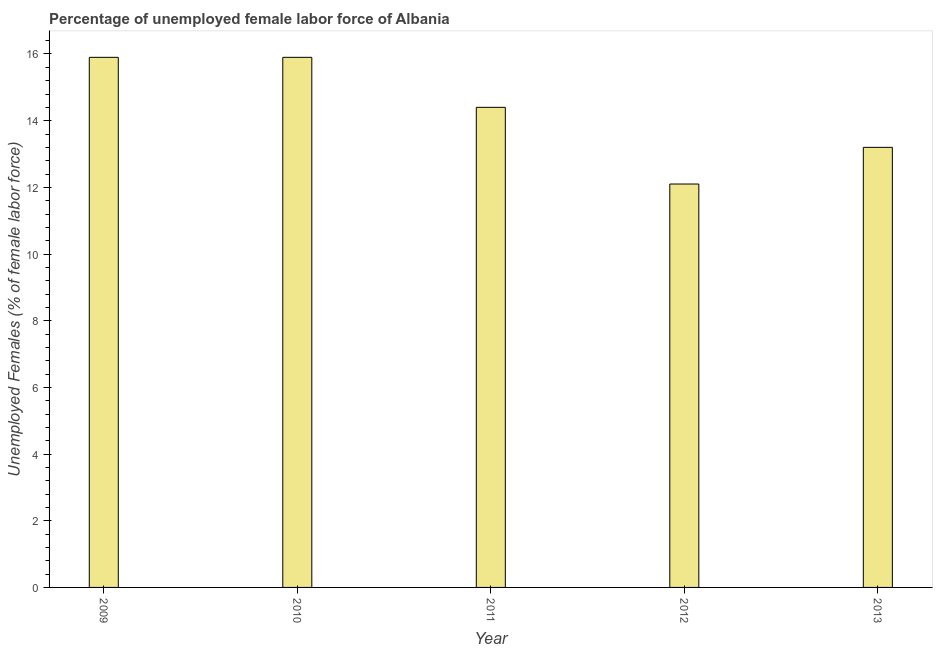Does the graph contain any zero values?
Give a very brief answer. No. Does the graph contain grids?
Keep it short and to the point. No. What is the title of the graph?
Provide a succinct answer. Percentage of unemployed female labor force of Albania. What is the label or title of the Y-axis?
Make the answer very short. Unemployed Females (% of female labor force). What is the total unemployed female labour force in 2012?
Provide a short and direct response. 12.1. Across all years, what is the maximum total unemployed female labour force?
Your response must be concise. 15.9. Across all years, what is the minimum total unemployed female labour force?
Provide a short and direct response. 12.1. In which year was the total unemployed female labour force minimum?
Offer a terse response. 2012. What is the sum of the total unemployed female labour force?
Provide a short and direct response. 71.5. What is the difference between the total unemployed female labour force in 2009 and 2012?
Ensure brevity in your answer.  3.8. What is the median total unemployed female labour force?
Give a very brief answer. 14.4. What is the ratio of the total unemployed female labour force in 2010 to that in 2012?
Offer a very short reply. 1.31. Is the difference between the total unemployed female labour force in 2012 and 2013 greater than the difference between any two years?
Provide a succinct answer. No. What is the difference between the highest and the second highest total unemployed female labour force?
Provide a succinct answer. 0. Is the sum of the total unemployed female labour force in 2009 and 2011 greater than the maximum total unemployed female labour force across all years?
Your answer should be compact. Yes. What is the difference between the highest and the lowest total unemployed female labour force?
Your answer should be compact. 3.8. Are all the bars in the graph horizontal?
Your response must be concise. No. What is the difference between two consecutive major ticks on the Y-axis?
Keep it short and to the point. 2. Are the values on the major ticks of Y-axis written in scientific E-notation?
Your answer should be compact. No. What is the Unemployed Females (% of female labor force) of 2009?
Ensure brevity in your answer.  15.9. What is the Unemployed Females (% of female labor force) of 2010?
Ensure brevity in your answer.  15.9. What is the Unemployed Females (% of female labor force) of 2011?
Make the answer very short. 14.4. What is the Unemployed Females (% of female labor force) of 2012?
Offer a terse response. 12.1. What is the Unemployed Females (% of female labor force) in 2013?
Your answer should be compact. 13.2. What is the difference between the Unemployed Females (% of female labor force) in 2009 and 2010?
Provide a short and direct response. 0. What is the difference between the Unemployed Females (% of female labor force) in 2009 and 2011?
Your answer should be compact. 1.5. What is the difference between the Unemployed Females (% of female labor force) in 2009 and 2012?
Your answer should be compact. 3.8. What is the difference between the Unemployed Females (% of female labor force) in 2010 and 2011?
Offer a very short reply. 1.5. What is the difference between the Unemployed Females (% of female labor force) in 2010 and 2012?
Your answer should be very brief. 3.8. What is the difference between the Unemployed Females (% of female labor force) in 2011 and 2012?
Provide a succinct answer. 2.3. What is the difference between the Unemployed Females (% of female labor force) in 2011 and 2013?
Give a very brief answer. 1.2. What is the ratio of the Unemployed Females (% of female labor force) in 2009 to that in 2010?
Provide a short and direct response. 1. What is the ratio of the Unemployed Females (% of female labor force) in 2009 to that in 2011?
Provide a short and direct response. 1.1. What is the ratio of the Unemployed Females (% of female labor force) in 2009 to that in 2012?
Your answer should be very brief. 1.31. What is the ratio of the Unemployed Females (% of female labor force) in 2009 to that in 2013?
Your response must be concise. 1.21. What is the ratio of the Unemployed Females (% of female labor force) in 2010 to that in 2011?
Your answer should be very brief. 1.1. What is the ratio of the Unemployed Females (% of female labor force) in 2010 to that in 2012?
Provide a short and direct response. 1.31. What is the ratio of the Unemployed Females (% of female labor force) in 2010 to that in 2013?
Make the answer very short. 1.21. What is the ratio of the Unemployed Females (% of female labor force) in 2011 to that in 2012?
Keep it short and to the point. 1.19. What is the ratio of the Unemployed Females (% of female labor force) in 2011 to that in 2013?
Provide a succinct answer. 1.09. What is the ratio of the Unemployed Females (% of female labor force) in 2012 to that in 2013?
Offer a terse response. 0.92. 